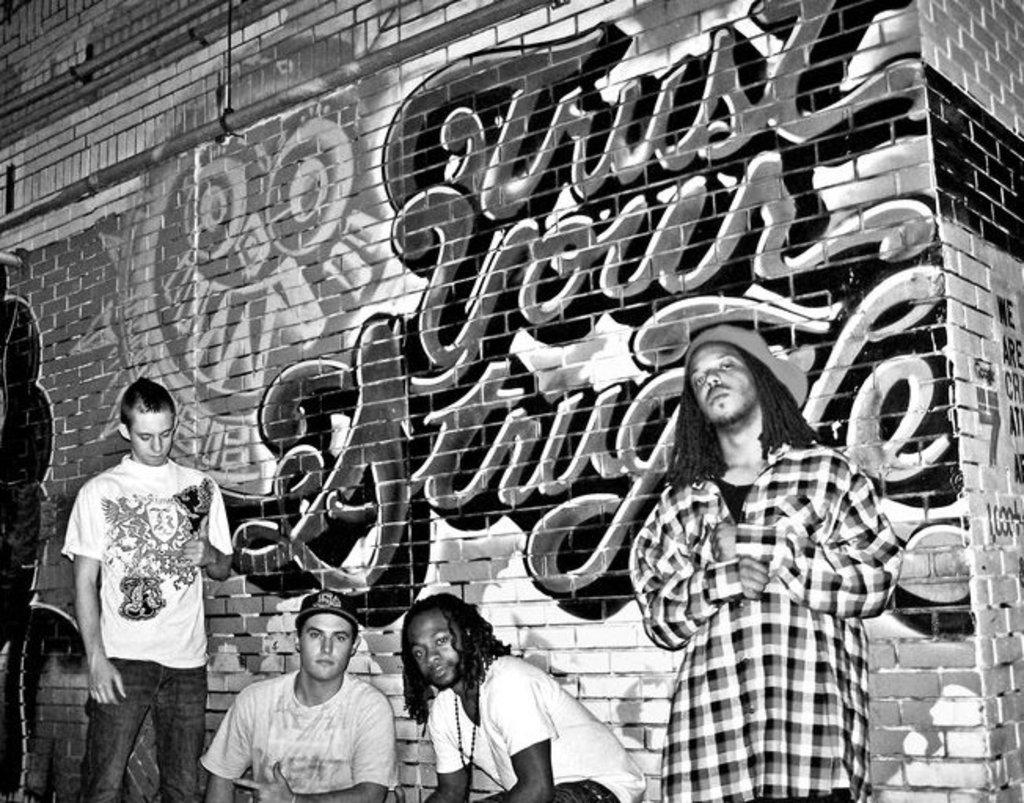What type of people are present in the image? There are men in the image. Can you describe any accessories the men are wearing? Some of the men are wearing caps. What is the background of the image made of? There is a brick wall in the image. Is there any artwork on the brick wall? Yes, there is a painting on the brick wall. What else can be seen in the image besides the men and the brick wall? There is text visible in the image. What type of boat can be seen in the image? There is no boat present in the image. What hobbies do the men in the image enjoy? The provided facts do not give any information about the men's hobbies. --- Facts: 1. There is a car in the image. 2. The car is red. 3. The car has four wheels. 4. There are people in the car. 5. The car is parked on the street. Absurd Topics: bird, ocean, mountain Conversation: What type of vehicle is in the image? There is a car in the image. What color is the car? The car is red. How many wheels does the car have? The car has four wheels. Are there any passengers in the car? Yes, there are people in the car. Where is the car located in the image? The car is parked on the street. Reasoning: Let's think step by step in order to produce the conversation. We start by identifying the main subject in the image, which is the car. Then, we expand the conversation to include other details about the car, such as its color and the number of wheels. Next, we mention the presence of passengers in the car. Finally, we describe the car's location, which is parked on the street. Absurd Question/Answer: Can you see any birds flying over the ocean in the image? There is no ocean or birds present in the image; it features a red car parked on the street with people inside. Is there a mountain visible in the background of the image? There is no mountain visible in the image; it only shows a red car parked on the street. 